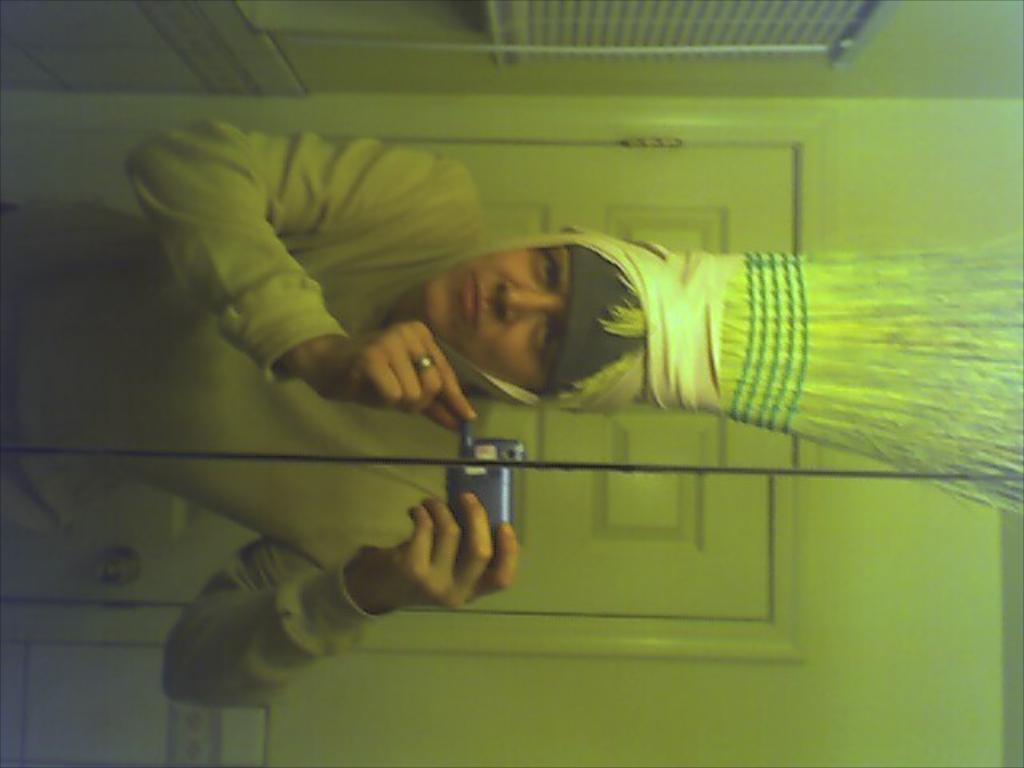What object is present in the image that can show reflections? There is a mirror in the image. What can be seen in the mirror's reflection? The reflection of a person, a door, and an object are visible in the mirror. What is the person wearing in the image? The person is wearing a costume in the image. What type of scarf is the person wearing in the image? There is no scarf visible in the image; the person is wearing a costume. How does the person lose their way in the image? There is no indication of the person losing their way in the image; they are simply standing in front of a mirror. 